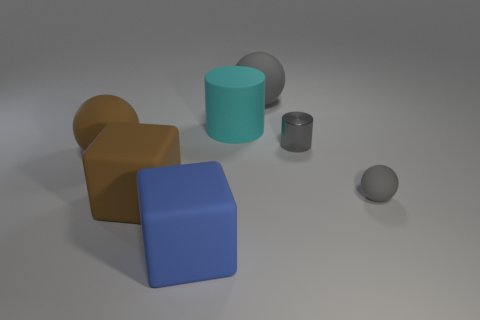There is a matte sphere that is on the right side of the large cyan cylinder and behind the tiny gray rubber sphere; what is its color?
Offer a terse response. Gray. Is the large ball that is in front of the large rubber cylinder made of the same material as the tiny gray cylinder?
Keep it short and to the point. No. There is a metal thing; is it the same color as the matte ball that is on the left side of the large blue cube?
Make the answer very short. No. There is a big cyan matte thing; are there any matte things behind it?
Make the answer very short. Yes. Does the rubber ball that is behind the large brown matte ball have the same size as the sphere to the left of the large gray thing?
Give a very brief answer. Yes. Is there a brown object that has the same size as the gray metallic cylinder?
Ensure brevity in your answer.  No. There is a object behind the cyan rubber object; does it have the same shape as the small shiny thing?
Offer a terse response. No. What material is the sphere behind the tiny metallic object?
Offer a very short reply. Rubber. What shape is the thing that is on the right side of the tiny object that is behind the tiny gray rubber object?
Ensure brevity in your answer.  Sphere. There is a big cyan thing; is it the same shape as the tiny gray matte thing that is behind the blue thing?
Make the answer very short. No. 